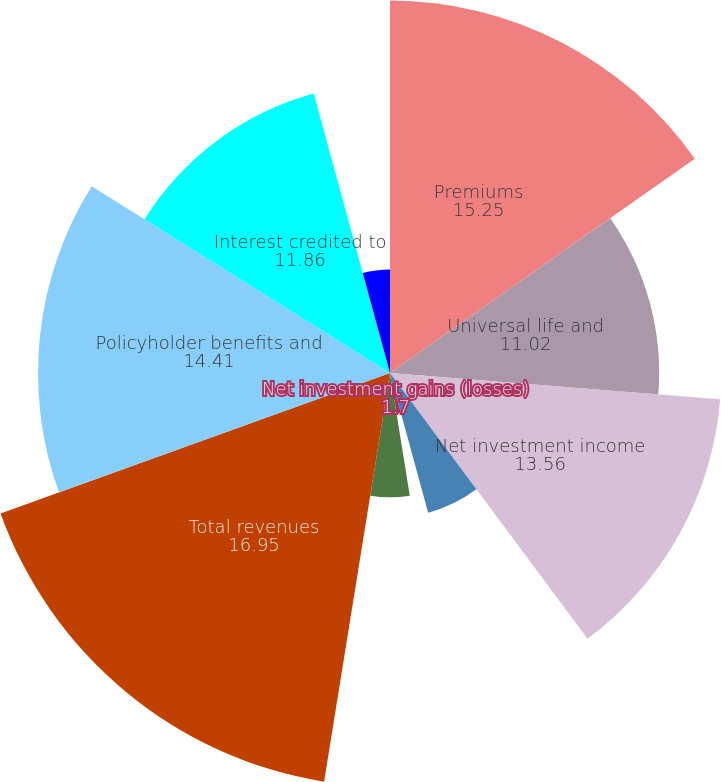Convert chart. <chart><loc_0><loc_0><loc_500><loc_500><pie_chart><fcel>Premiums<fcel>Universal life and<fcel>Net investment income<fcel>Other revenues<fcel>Net investment gains (losses)<fcel>Net derivative gains (losses)<fcel>Total revenues<fcel>Policyholder benefits and<fcel>Interest credited to<fcel>Policyholder dividends<nl><fcel>15.25%<fcel>11.02%<fcel>13.56%<fcel>5.93%<fcel>1.7%<fcel>5.09%<fcel>16.95%<fcel>14.41%<fcel>11.86%<fcel>4.24%<nl></chart> 